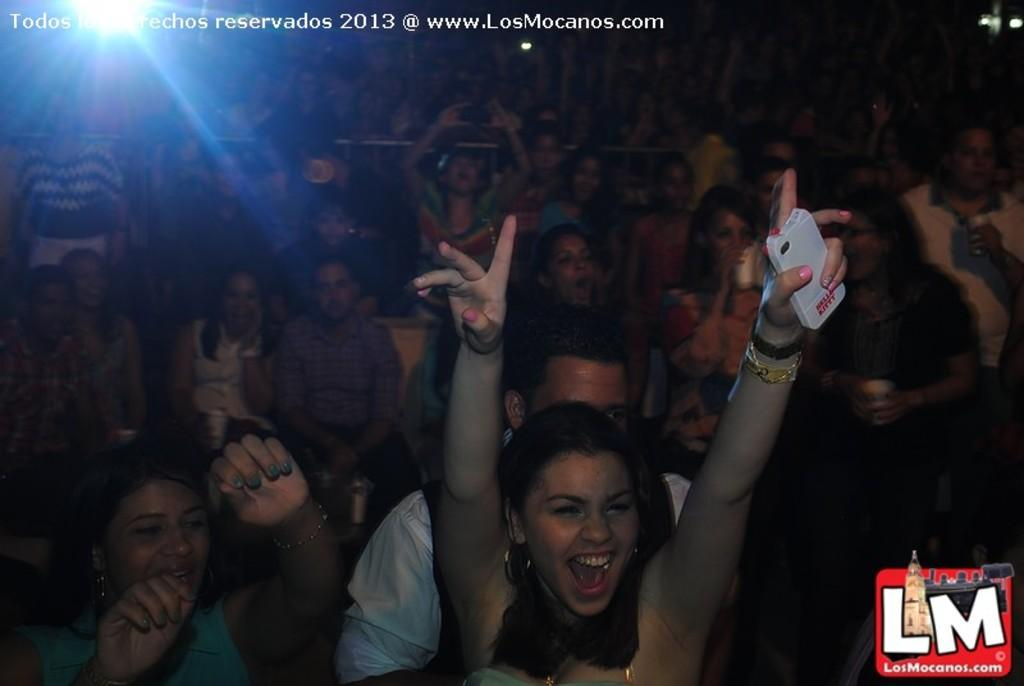What is happening in the foreground of the image? There are people in the foreground of the image, with some standing and others sitting. Can you describe the positions of the people in the image? Some people are standing, while others are sitting. What can be seen in the background of the image? There is light in the background of the image. What is present at the top side of the image? There is text at the top side of the image. How many matches are being used by the people in the image? There are no matches present in the image; it features people standing and sitting. What type of space is depicted in the image? The image does not depict a specific type of space; it simply shows people in a setting with light in the background and text at the top side. 